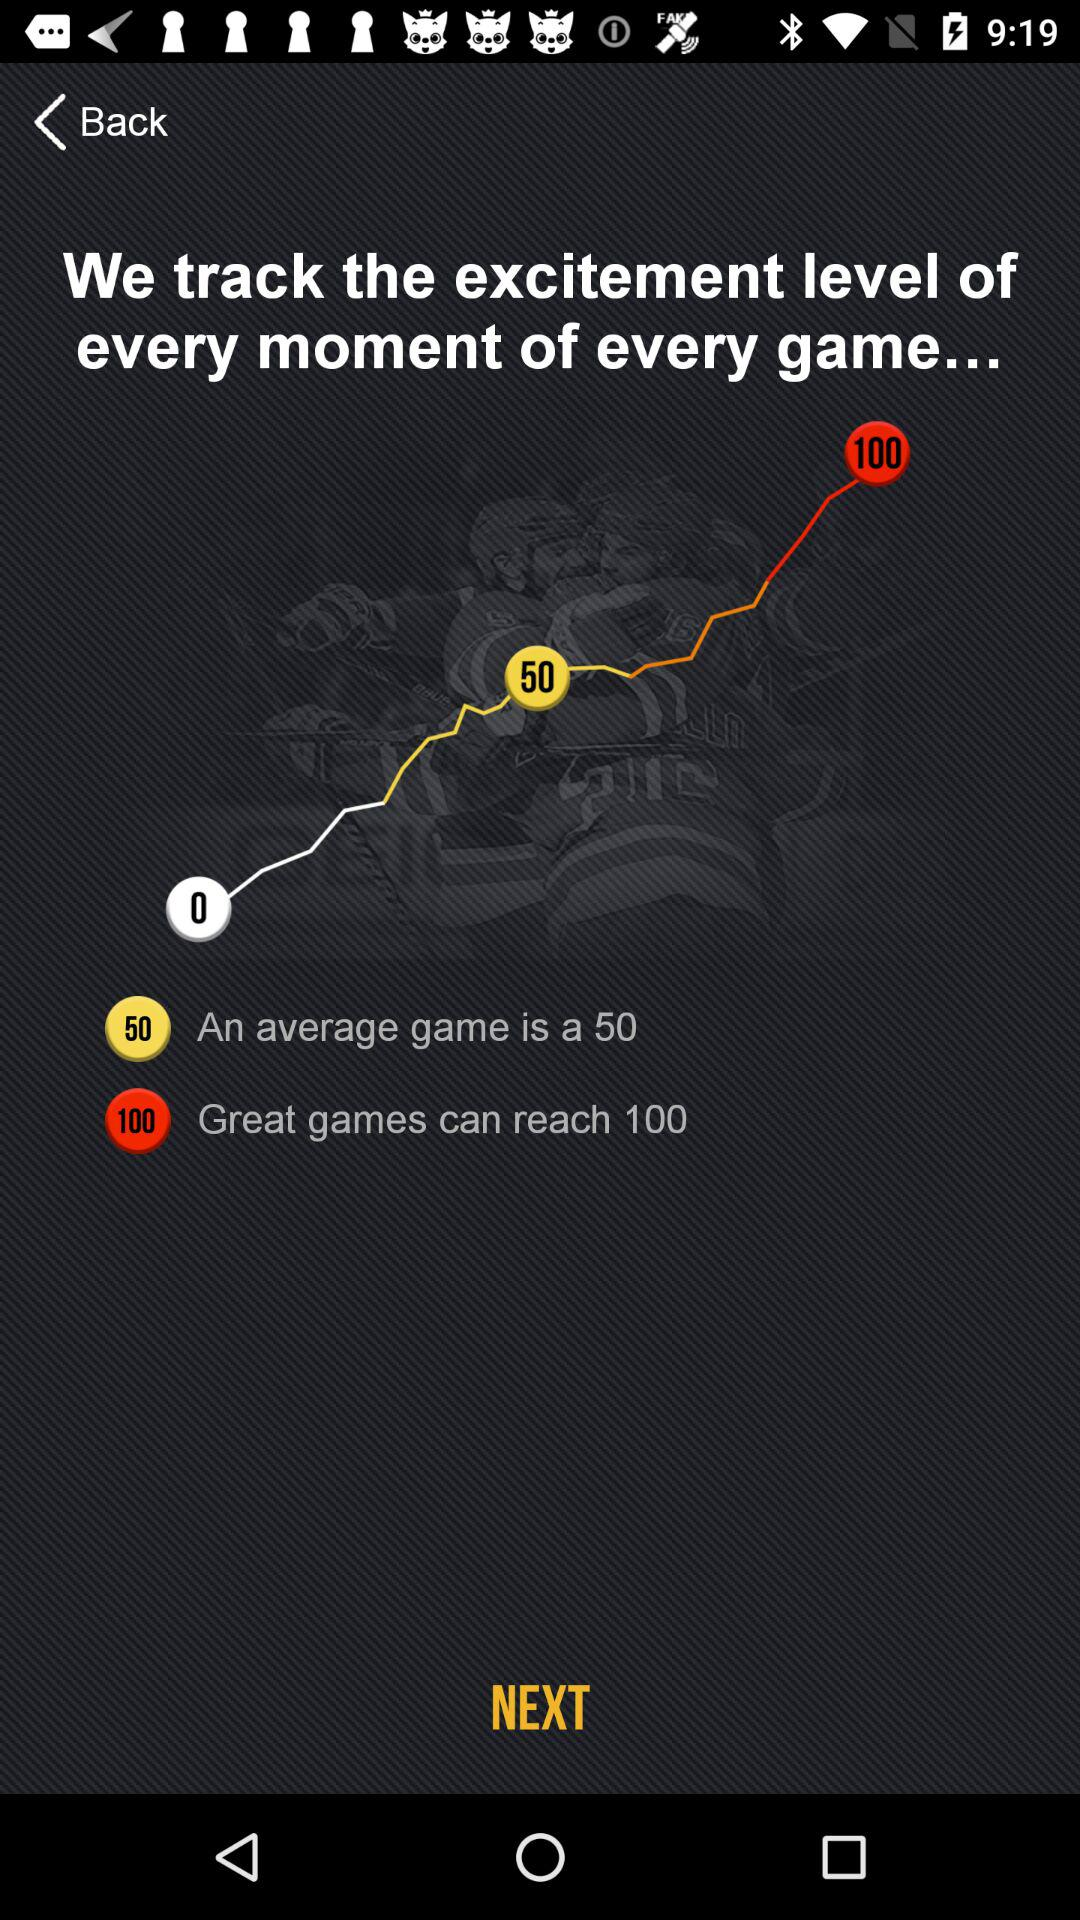What is the average game level? The average game level is 50. 